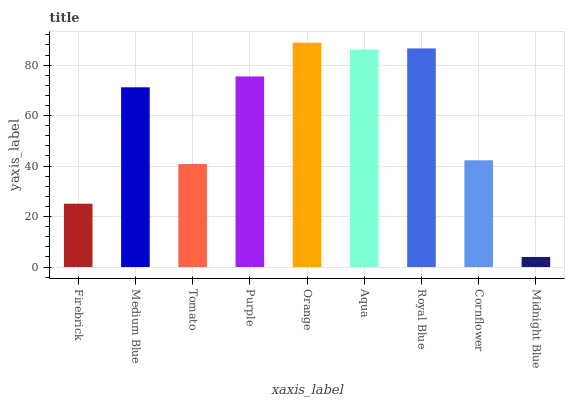Is Midnight Blue the minimum?
Answer yes or no. Yes. Is Orange the maximum?
Answer yes or no. Yes. Is Medium Blue the minimum?
Answer yes or no. No. Is Medium Blue the maximum?
Answer yes or no. No. Is Medium Blue greater than Firebrick?
Answer yes or no. Yes. Is Firebrick less than Medium Blue?
Answer yes or no. Yes. Is Firebrick greater than Medium Blue?
Answer yes or no. No. Is Medium Blue less than Firebrick?
Answer yes or no. No. Is Medium Blue the high median?
Answer yes or no. Yes. Is Medium Blue the low median?
Answer yes or no. Yes. Is Royal Blue the high median?
Answer yes or no. No. Is Orange the low median?
Answer yes or no. No. 